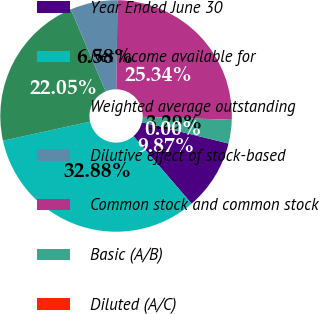Convert chart to OTSL. <chart><loc_0><loc_0><loc_500><loc_500><pie_chart><fcel>Year Ended June 30<fcel>Net income available for<fcel>Weighted average outstanding<fcel>Dilutive effect of stock-based<fcel>Common stock and common stock<fcel>Basic (A/B)<fcel>Diluted (A/C)<nl><fcel>9.87%<fcel>32.88%<fcel>22.05%<fcel>6.58%<fcel>25.34%<fcel>3.29%<fcel>0.0%<nl></chart> 